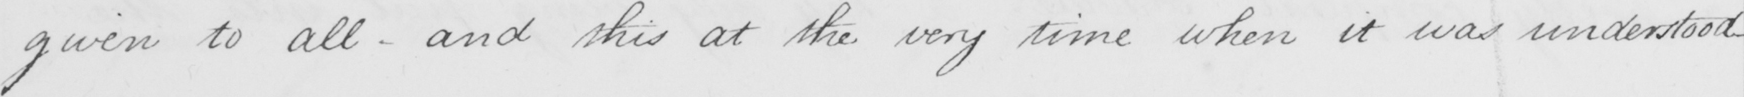Please transcribe the handwritten text in this image. given to all - and this at the very time when it was understood _ 